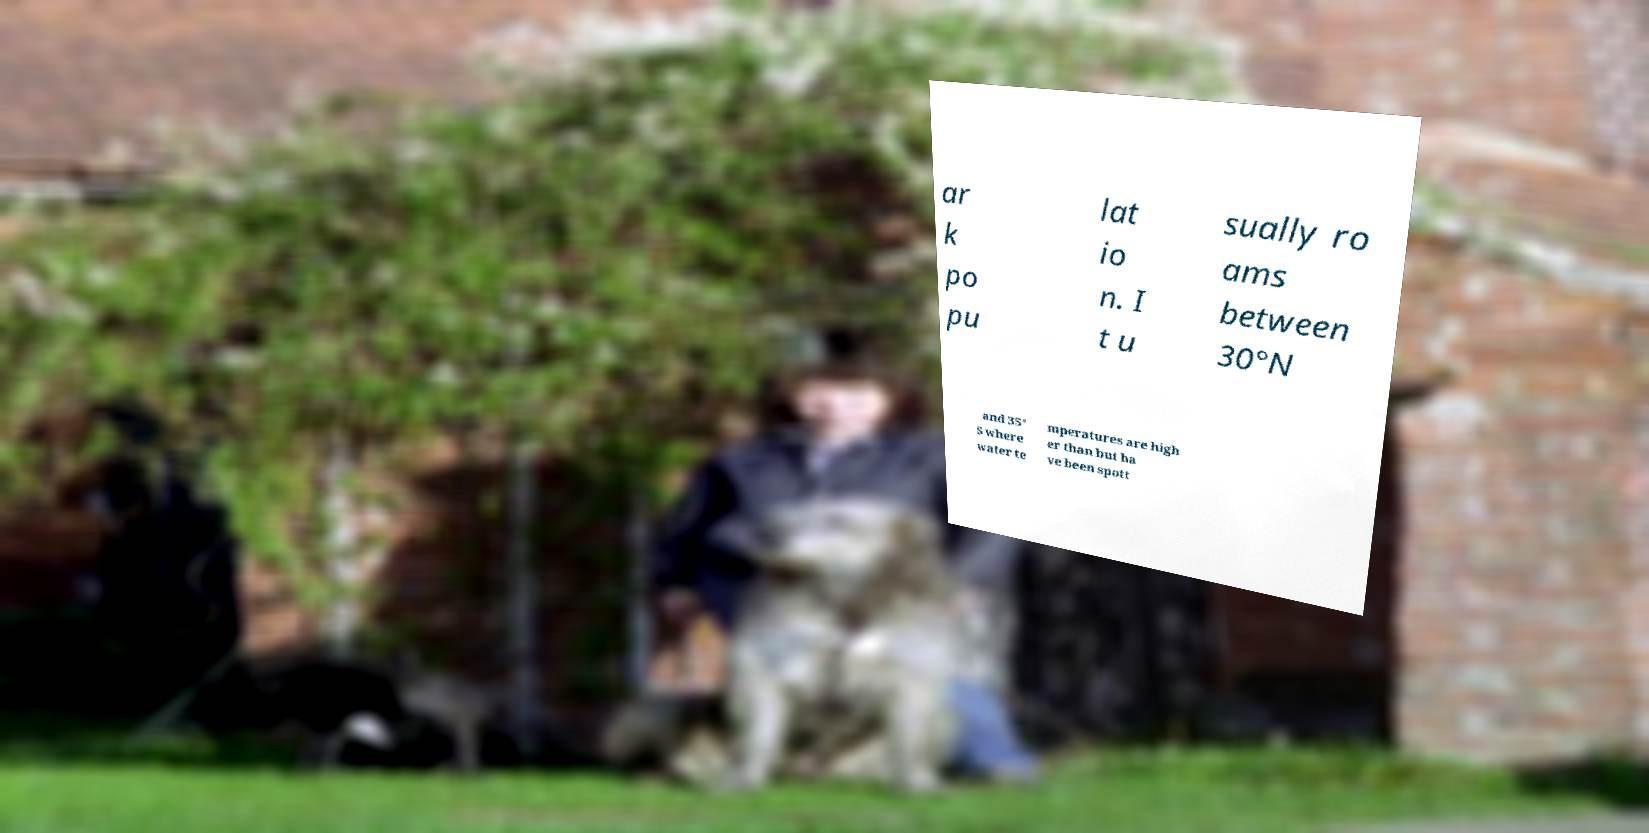What messages or text are displayed in this image? I need them in a readable, typed format. ar k po pu lat io n. I t u sually ro ams between 30°N and 35° S where water te mperatures are high er than but ha ve been spott 